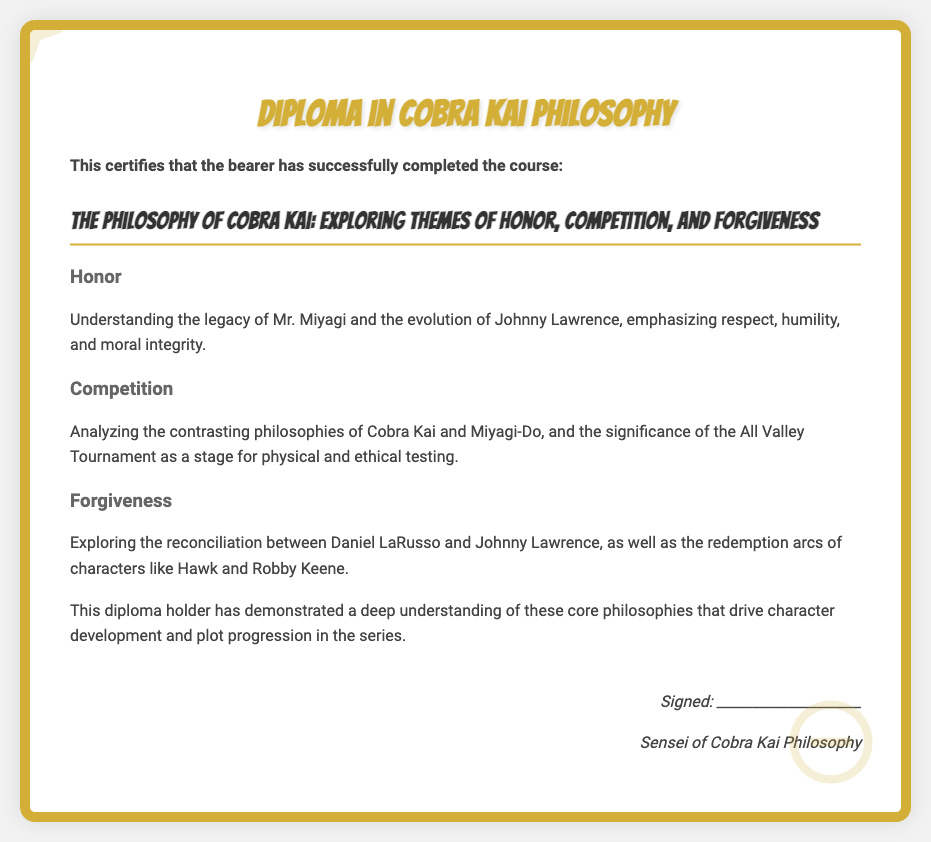what is the title of the course? The title of the course is explicitly stated in the document.
Answer: The Philosophy of Cobra Kai: Exploring Themes of Honor, Competition, and Forgiveness who is the signer of the diploma? The signer of the diploma is identified in the signature section of the document.
Answer: Sensei of Cobra Kai Philosophy what theme focuses on Mr. Miyagi's legacy? The theme specifically about Mr. Miyagi's legacy is mentioned under one of the sections of the document.
Answer: Honor which two philosophies are contrasted in the document? The document explicitly mentions the two philosophies being compared within its content.
Answer: Cobra Kai and Miyagi-Do what character arc is explored in the context of forgiveness? The document mentions a specific character in relation to the theme of forgiveness.
Answer: Johnny Lawrence how many core philosophies are mentioned in the diploma? The document lists the main themes, which can be counted to determine the number of philosophies discussed.
Answer: Three what event serves as a significant stage for testing in the competition theme? The document points out a specific event relevant to the theme of competition.
Answer: All Valley Tournament 